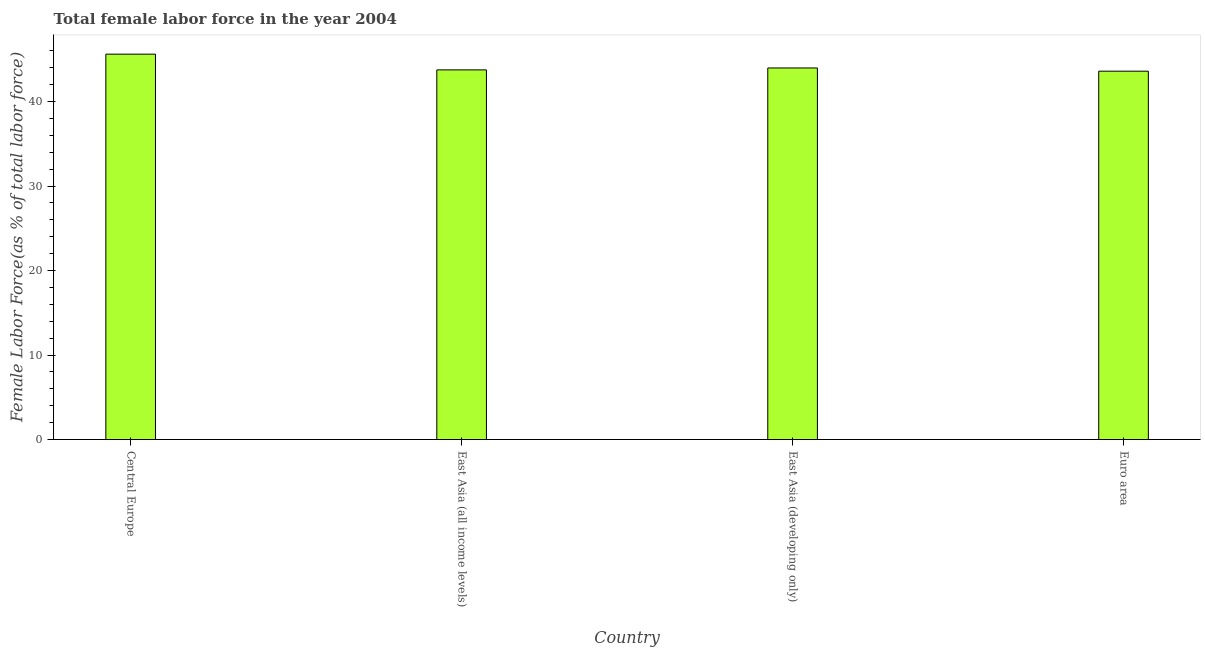Does the graph contain any zero values?
Offer a very short reply. No. Does the graph contain grids?
Offer a very short reply. No. What is the title of the graph?
Your response must be concise. Total female labor force in the year 2004. What is the label or title of the Y-axis?
Make the answer very short. Female Labor Force(as % of total labor force). What is the total female labor force in East Asia (all income levels)?
Offer a terse response. 43.74. Across all countries, what is the maximum total female labor force?
Your response must be concise. 45.61. Across all countries, what is the minimum total female labor force?
Give a very brief answer. 43.59. In which country was the total female labor force maximum?
Provide a succinct answer. Central Europe. What is the sum of the total female labor force?
Your answer should be very brief. 176.91. What is the difference between the total female labor force in East Asia (all income levels) and East Asia (developing only)?
Ensure brevity in your answer.  -0.23. What is the average total female labor force per country?
Offer a very short reply. 44.23. What is the median total female labor force?
Your response must be concise. 43.86. In how many countries, is the total female labor force greater than 14 %?
Make the answer very short. 4. Is the difference between the total female labor force in Central Europe and Euro area greater than the difference between any two countries?
Ensure brevity in your answer.  Yes. What is the difference between the highest and the second highest total female labor force?
Give a very brief answer. 1.64. What is the difference between the highest and the lowest total female labor force?
Your response must be concise. 2.02. In how many countries, is the total female labor force greater than the average total female labor force taken over all countries?
Your response must be concise. 1. How many bars are there?
Make the answer very short. 4. Are all the bars in the graph horizontal?
Your answer should be compact. No. Are the values on the major ticks of Y-axis written in scientific E-notation?
Your answer should be very brief. No. What is the Female Labor Force(as % of total labor force) in Central Europe?
Provide a short and direct response. 45.61. What is the Female Labor Force(as % of total labor force) in East Asia (all income levels)?
Your answer should be very brief. 43.74. What is the Female Labor Force(as % of total labor force) of East Asia (developing only)?
Your response must be concise. 43.97. What is the Female Labor Force(as % of total labor force) in Euro area?
Keep it short and to the point. 43.59. What is the difference between the Female Labor Force(as % of total labor force) in Central Europe and East Asia (all income levels)?
Your response must be concise. 1.86. What is the difference between the Female Labor Force(as % of total labor force) in Central Europe and East Asia (developing only)?
Make the answer very short. 1.64. What is the difference between the Female Labor Force(as % of total labor force) in Central Europe and Euro area?
Give a very brief answer. 2.02. What is the difference between the Female Labor Force(as % of total labor force) in East Asia (all income levels) and East Asia (developing only)?
Make the answer very short. -0.23. What is the difference between the Female Labor Force(as % of total labor force) in East Asia (all income levels) and Euro area?
Ensure brevity in your answer.  0.15. What is the difference between the Female Labor Force(as % of total labor force) in East Asia (developing only) and Euro area?
Make the answer very short. 0.38. What is the ratio of the Female Labor Force(as % of total labor force) in Central Europe to that in East Asia (all income levels)?
Keep it short and to the point. 1.04. What is the ratio of the Female Labor Force(as % of total labor force) in Central Europe to that in Euro area?
Provide a succinct answer. 1.05. What is the ratio of the Female Labor Force(as % of total labor force) in East Asia (all income levels) to that in East Asia (developing only)?
Offer a terse response. 0.99. What is the ratio of the Female Labor Force(as % of total labor force) in East Asia (developing only) to that in Euro area?
Offer a very short reply. 1.01. 